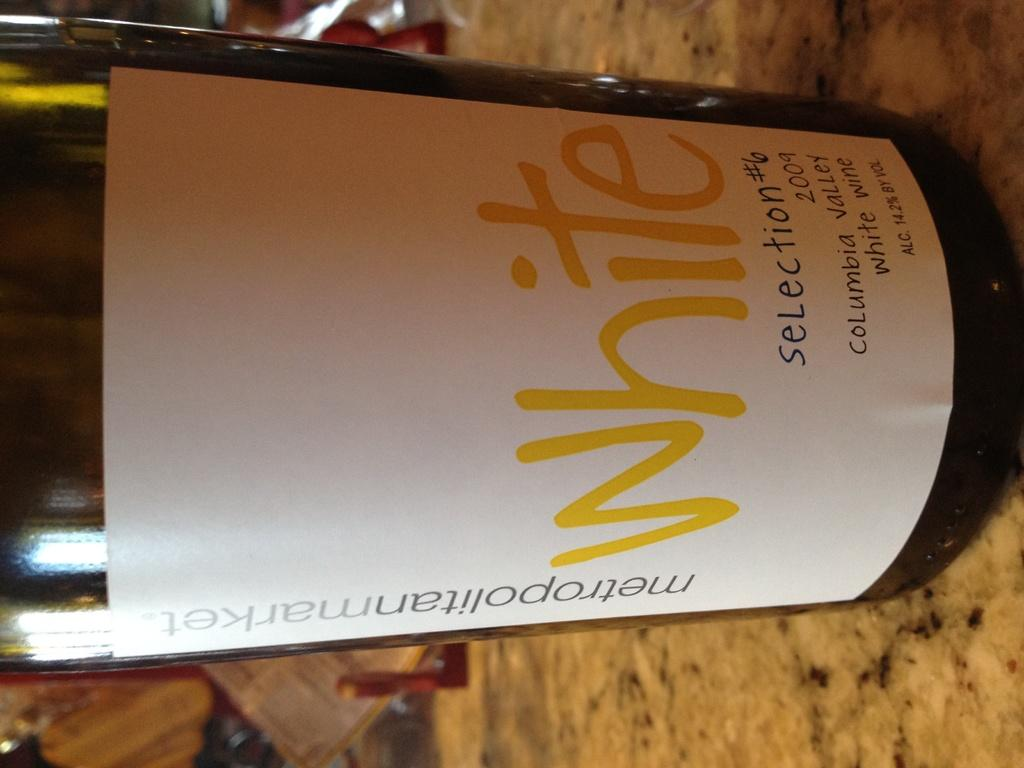<image>
Summarize the visual content of the image. A bottle of white wine from metropolitanmarket on a granite table 